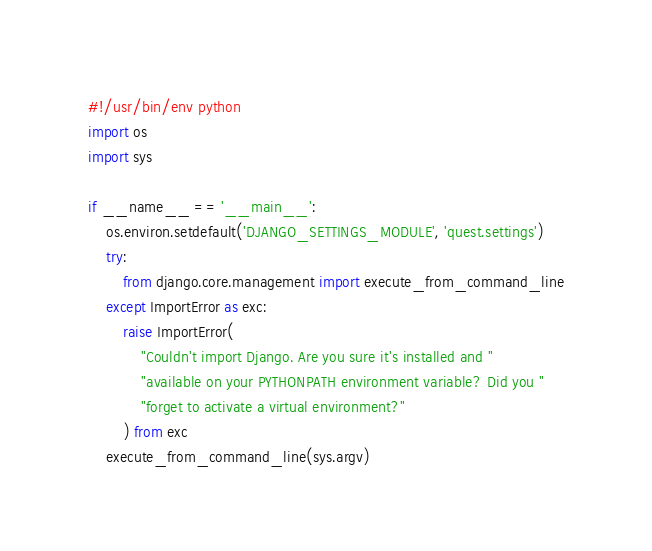<code> <loc_0><loc_0><loc_500><loc_500><_Python_>#!/usr/bin/env python
import os
import sys

if __name__ == '__main__':
    os.environ.setdefault('DJANGO_SETTINGS_MODULE', 'quest.settings')
    try:
        from django.core.management import execute_from_command_line
    except ImportError as exc:
        raise ImportError(
            "Couldn't import Django. Are you sure it's installed and "
            "available on your PYTHONPATH environment variable? Did you "
            "forget to activate a virtual environment?"
        ) from exc
    execute_from_command_line(sys.argv)
</code> 